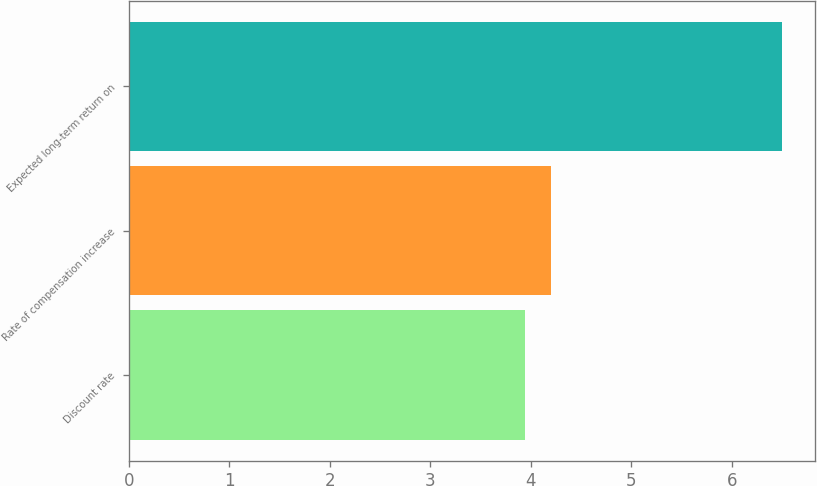Convert chart. <chart><loc_0><loc_0><loc_500><loc_500><bar_chart><fcel>Discount rate<fcel>Rate of compensation increase<fcel>Expected long-term return on<nl><fcel>3.94<fcel>4.2<fcel>6.5<nl></chart> 